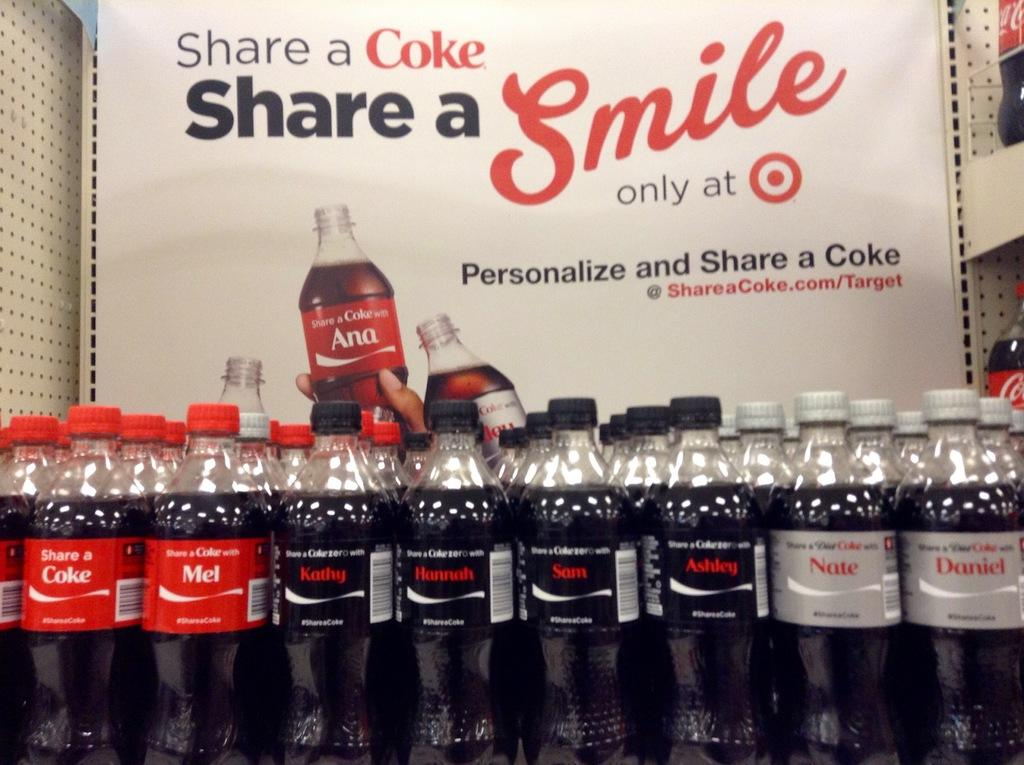<image>
Offer a succinct explanation of the picture presented. Sign that says share a coke share a smile only at target behind bottles of coke 